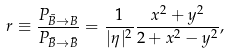Convert formula to latex. <formula><loc_0><loc_0><loc_500><loc_500>r \equiv \frac { P _ { \bar { B } \rightarrow { B } } } { P _ { \bar { B } \rightarrow \bar { B } } } = \frac { 1 } { | \eta | ^ { 2 } } \frac { x ^ { 2 } + y ^ { 2 } } { 2 + x ^ { 2 } - y ^ { 2 } } ,</formula> 